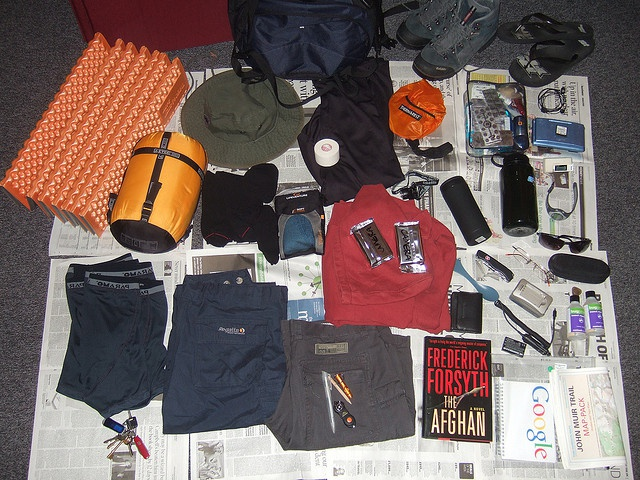Describe the objects in this image and their specific colors. I can see backpack in black, gray, and darkgray tones, handbag in black and gray tones, book in black, maroon, and red tones, cell phone in black, darkblue, blue, navy, and gray tones, and knife in black and gray tones in this image. 